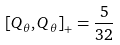Convert formula to latex. <formula><loc_0><loc_0><loc_500><loc_500>\left [ Q _ { \theta } , Q _ { \theta } \right ] _ { + } = \frac { 5 } { 3 2 }</formula> 